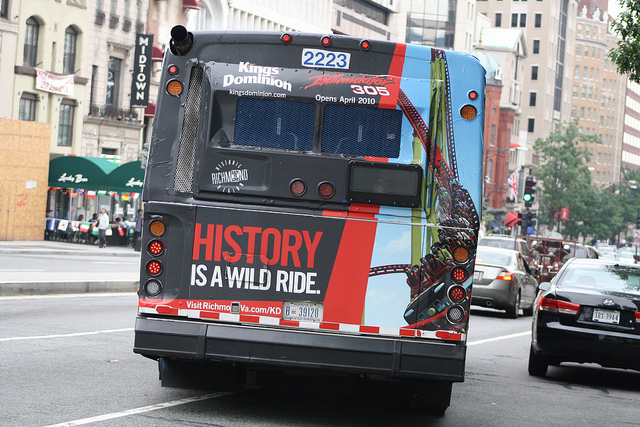Please extract the text content from this image. HISTORY IS WILD RIDE A Wingsdomlefan.com 2010 April Opens 305 305 2223 Kings Dominion RICHMOND 39120 Va.com/KD VisitRichma MIDTOWN 